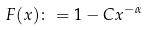Convert formula to latex. <formula><loc_0><loc_0><loc_500><loc_500>F ( x ) \colon = 1 - C x ^ { - \alpha }</formula> 